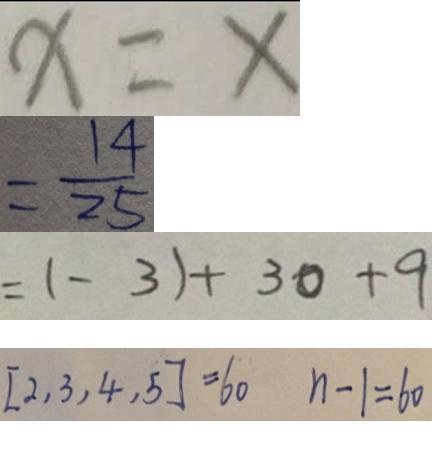Convert formula to latex. <formula><loc_0><loc_0><loc_500><loc_500>x = x 
 = \frac { 1 4 } { 2 5 } 
 = ( - 3 ) + 3 0 + 9 
 [ 2 , 3 , 4 , 5 ] = 6 0 n - 1 = 6 0</formula> 